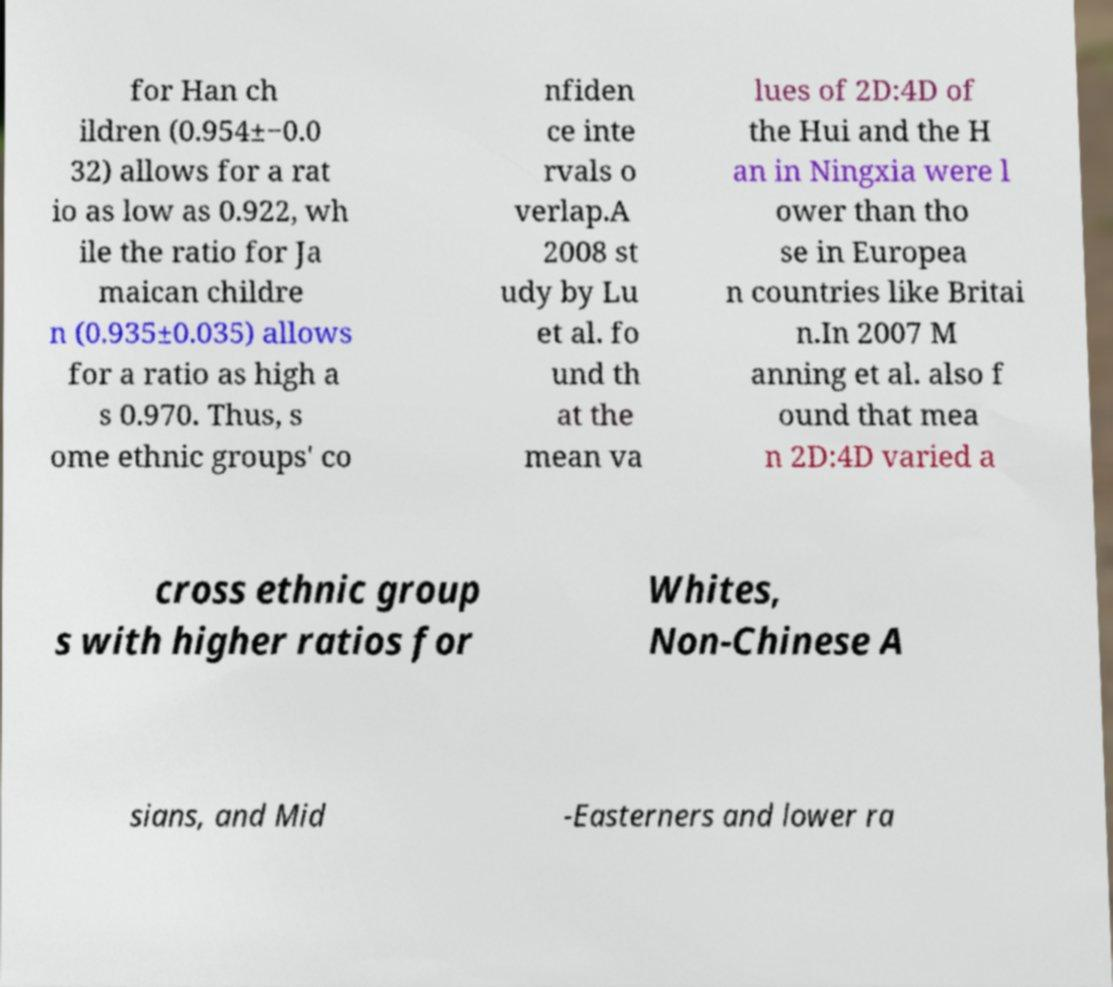Can you accurately transcribe the text from the provided image for me? for Han ch ildren (0.954±−0.0 32) allows for a rat io as low as 0.922, wh ile the ratio for Ja maican childre n (0.935±0.035) allows for a ratio as high a s 0.970. Thus, s ome ethnic groups' co nfiden ce inte rvals o verlap.A 2008 st udy by Lu et al. fo und th at the mean va lues of 2D:4D of the Hui and the H an in Ningxia were l ower than tho se in Europea n countries like Britai n.In 2007 M anning et al. also f ound that mea n 2D:4D varied a cross ethnic group s with higher ratios for Whites, Non-Chinese A sians, and Mid -Easterners and lower ra 